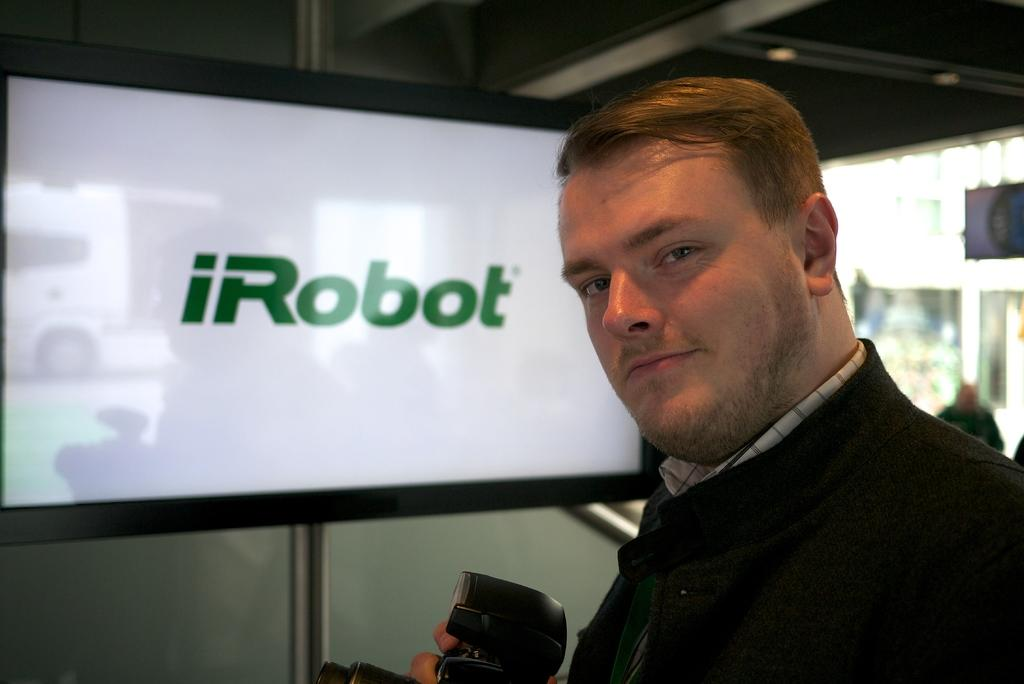What is the man in the image doing? The man is holding a camera with his hand. How does the man appear in the image? The man is smiling. Can you describe the person in the background of the image? There is a person in the background of the image, but no specific details are provided. What is on the wall in the background? There is a screen on the wall in the background. What else can be seen in the background of the image? There are objects visible in the background. What type of marble is the man using to take the picture in the image? There is no marble present in the image; the man is holding a camera, not a marble. What is the income of the person in the background of the image? There is no information about the income of the person in the background of the image. 